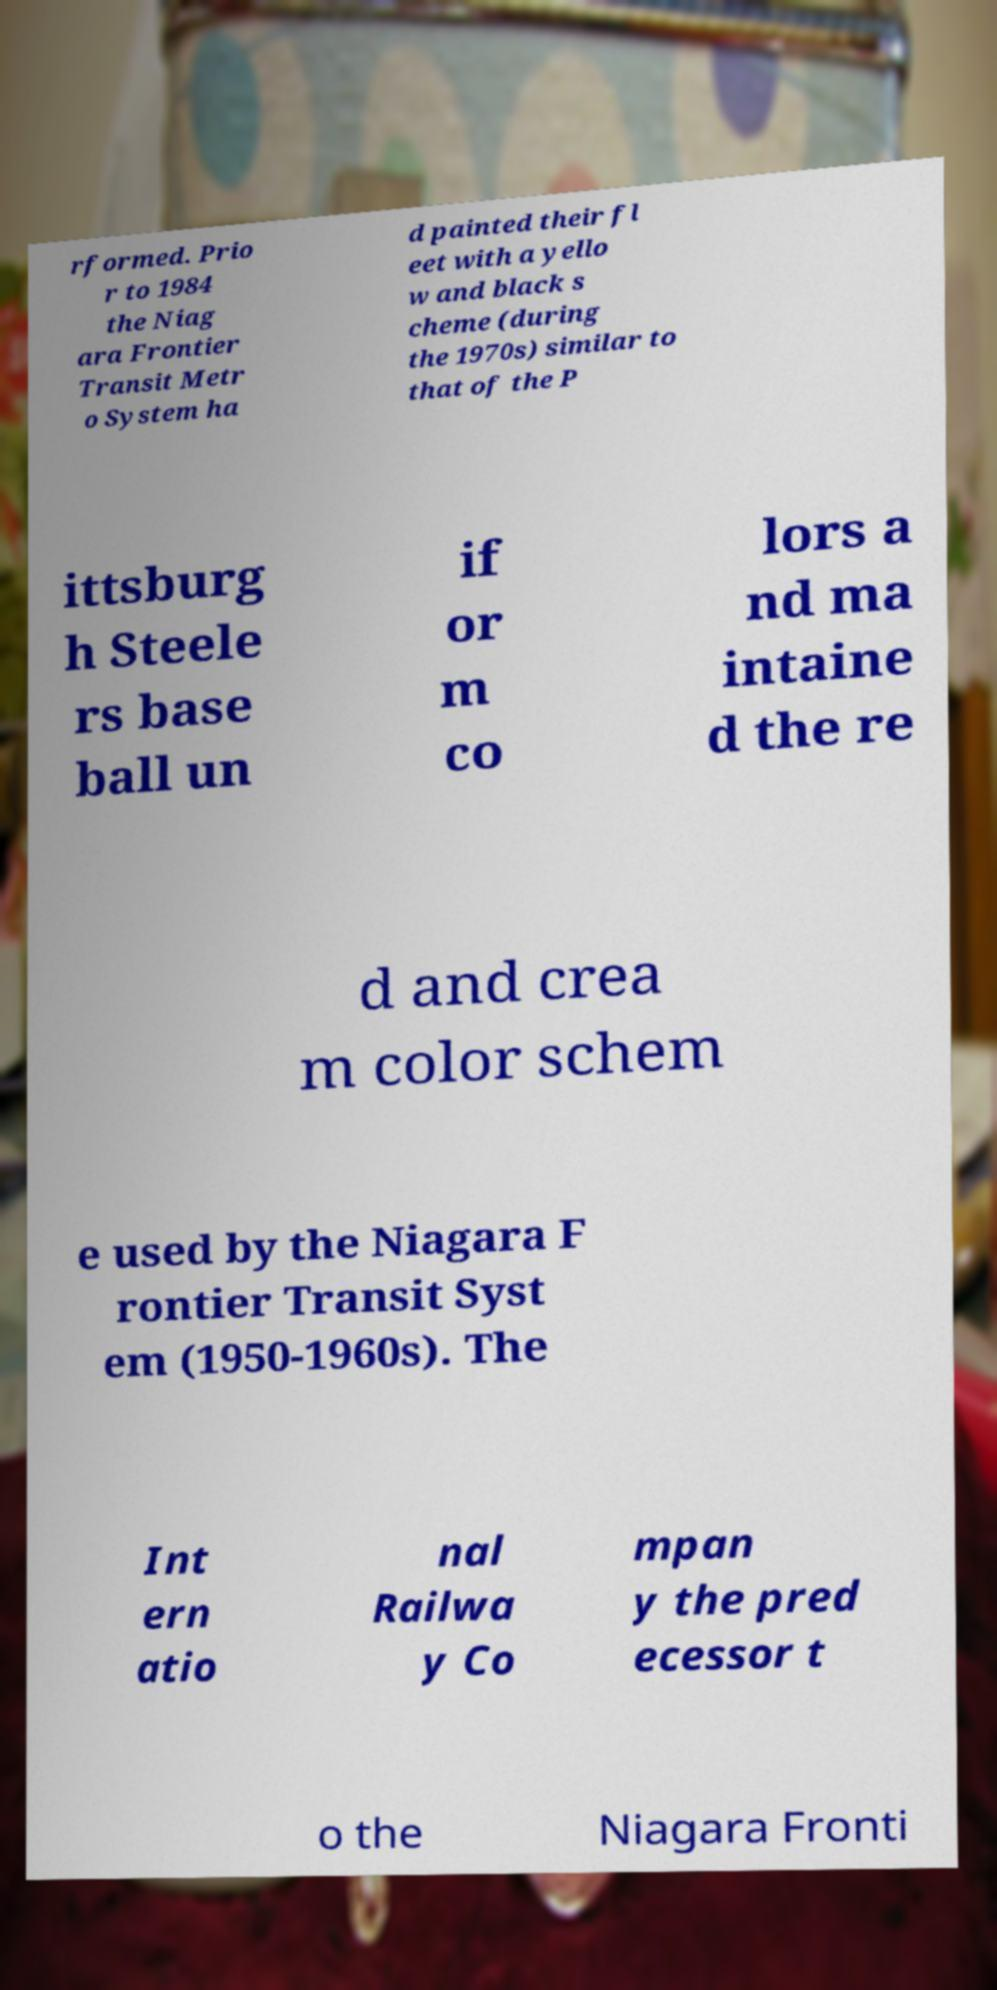Please identify and transcribe the text found in this image. rformed. Prio r to 1984 the Niag ara Frontier Transit Metr o System ha d painted their fl eet with a yello w and black s cheme (during the 1970s) similar to that of the P ittsburg h Steele rs base ball un if or m co lors a nd ma intaine d the re d and crea m color schem e used by the Niagara F rontier Transit Syst em (1950-1960s). The Int ern atio nal Railwa y Co mpan y the pred ecessor t o the Niagara Fronti 